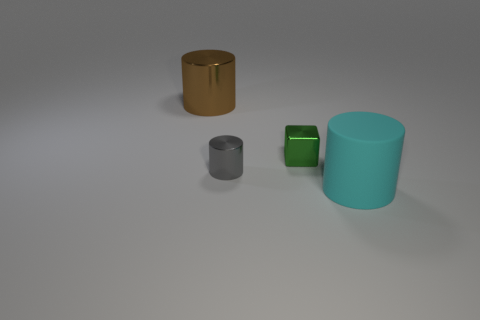Add 2 gray spheres. How many objects exist? 6 Subtract all cylinders. How many objects are left? 1 Add 2 brown cylinders. How many brown cylinders are left? 3 Add 4 tiny blocks. How many tiny blocks exist? 5 Subtract 0 gray cubes. How many objects are left? 4 Subtract all small gray things. Subtract all brown cylinders. How many objects are left? 2 